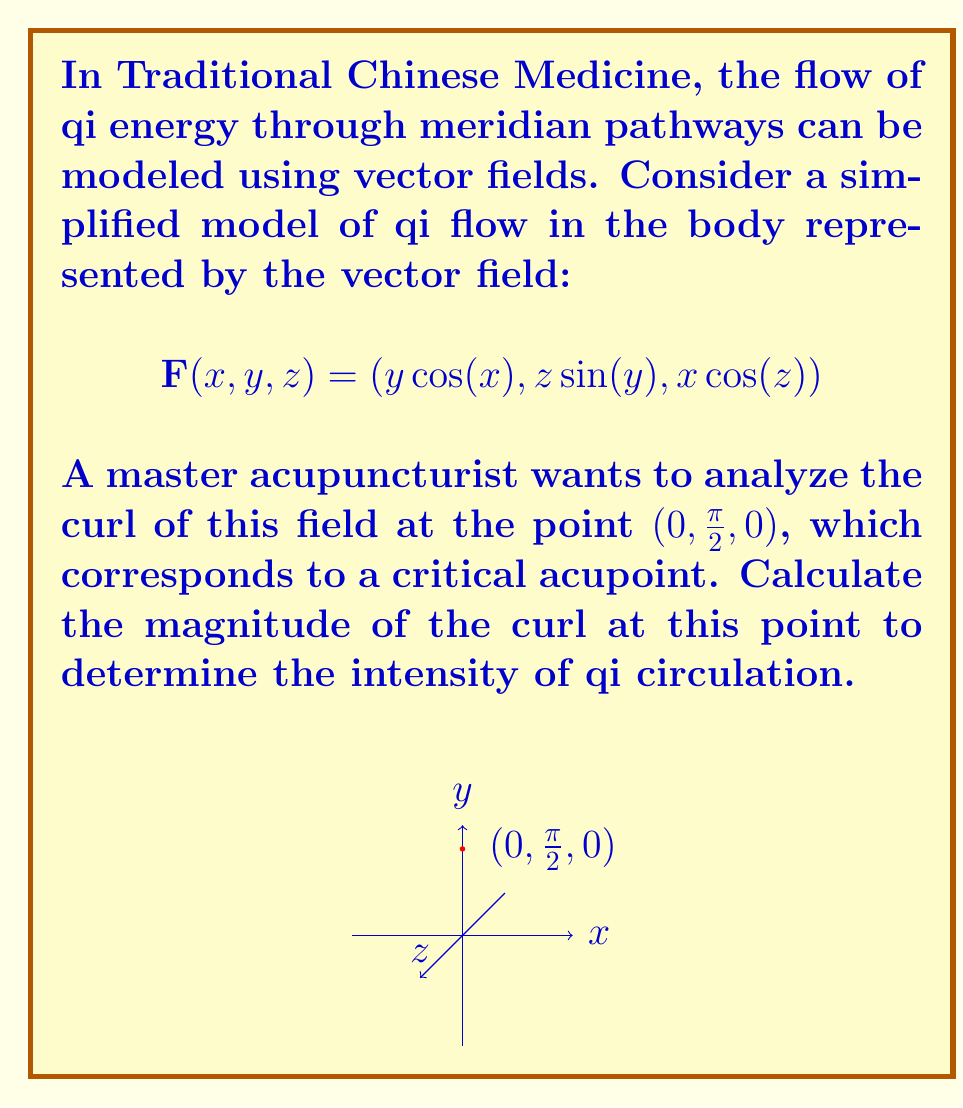Can you answer this question? To solve this problem, we'll follow these steps:

1) Recall the formula for curl in 3D:
   $$\text{curl }\mathbf{F} = \nabla \times \mathbf{F} = \left(\frac{\partial F_z}{\partial y} - \frac{\partial F_y}{\partial z}, \frac{\partial F_x}{\partial z} - \frac{\partial F_z}{\partial x}, \frac{\partial F_y}{\partial x} - \frac{\partial F_x}{\partial y}\right)$$

2) Calculate the partial derivatives:
   $\frac{\partial F_z}{\partial y} = 0$
   $\frac{\partial F_y}{\partial z} = \sin(y)$
   $\frac{\partial F_x}{\partial z} = 0$
   $\frac{\partial F_z}{\partial x} = -z\sin(z)$
   $\frac{\partial F_y}{\partial x} = 0$
   $\frac{\partial F_x}{\partial y} = \cos(x)$

3) Substitute these into the curl formula:
   $$\text{curl }\mathbf{F} = (0 - \sin(y), 0 - (-z\sin(z)), 0 - \cos(x))$$
   $$= (-\sin(y), z\sin(z), -\cos(x))$$

4) Evaluate at the point $(0, \frac{\pi}{2}, 0)$:
   $$\text{curl }\mathbf{F}(0, \frac{\pi}{2}, 0) = (-\sin(\frac{\pi}{2}), 0\cdot\sin(0), -\cos(0))$$
   $$= (-1, 0, -1)$$

5) Calculate the magnitude of the curl:
   $$|\text{curl }\mathbf{F}(0, \frac{\pi}{2}, 0)| = \sqrt{(-1)^2 + 0^2 + (-1)^2} = \sqrt{2}$$

The magnitude of the curl at $(0, \frac{\pi}{2}, 0)$ is $\sqrt{2}$, indicating the intensity of qi circulation at this critical acupoint.
Answer: $\sqrt{2}$ 